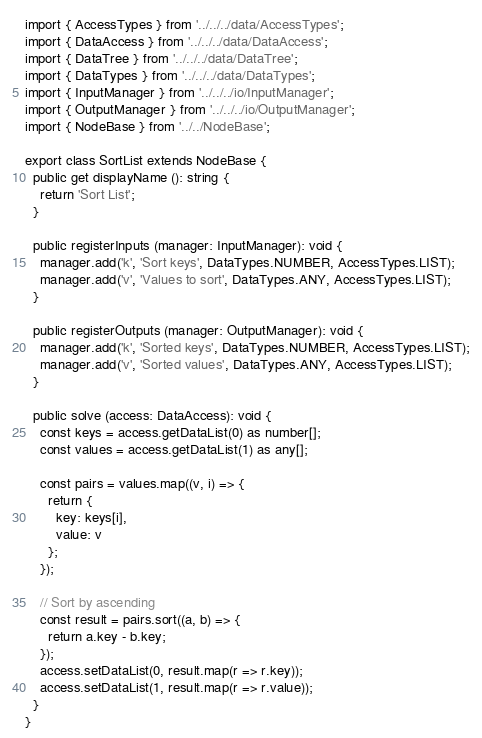<code> <loc_0><loc_0><loc_500><loc_500><_TypeScript_>
import { AccessTypes } from '../../../data/AccessTypes';
import { DataAccess } from '../../../data/DataAccess';
import { DataTree } from '../../../data/DataTree';
import { DataTypes } from '../../../data/DataTypes';
import { InputManager } from '../../../io/InputManager';
import { OutputManager } from '../../../io/OutputManager';
import { NodeBase } from '../../NodeBase';

export class SortList extends NodeBase {
  public get displayName (): string {
    return 'Sort List';
  }

  public registerInputs (manager: InputManager): void {
    manager.add('k', 'Sort keys', DataTypes.NUMBER, AccessTypes.LIST);
    manager.add('v', 'Values to sort', DataTypes.ANY, AccessTypes.LIST);
  }

  public registerOutputs (manager: OutputManager): void {
    manager.add('k', 'Sorted keys', DataTypes.NUMBER, AccessTypes.LIST);
    manager.add('v', 'Sorted values', DataTypes.ANY, AccessTypes.LIST);
  }

  public solve (access: DataAccess): void {
    const keys = access.getDataList(0) as number[];
    const values = access.getDataList(1) as any[];

    const pairs = values.map((v, i) => {
      return {
        key: keys[i],
        value: v
      };
    });

    // Sort by ascending
    const result = pairs.sort((a, b) => {
      return a.key - b.key;
    });
    access.setDataList(0, result.map(r => r.key));
    access.setDataList(1, result.map(r => r.value));
  }
}
</code> 